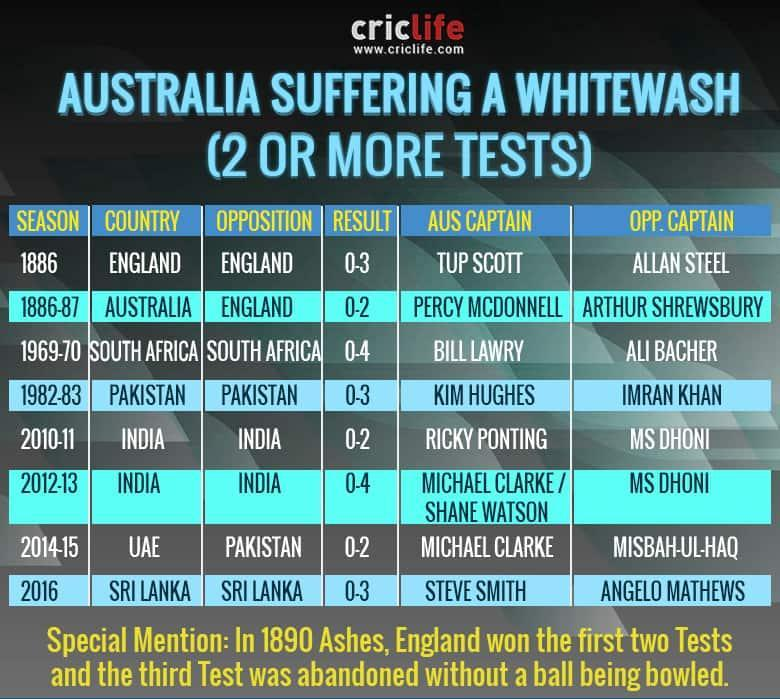Where was the England-Australia test series played during 1886-87?
Answer the question with a short phrase. AUSTRALIA Who was the captain of Pakistan in the test series against Australia in 1982-83? IMRAN KHAN What is the match result of England-Australia test series in 1886? 0-3 Who was the captain of Australia during the India-Australia test series in 2010-11? RICKY PONTING Where was the Pakistan-Australia test series played during 2014-15? UAE Who won the test series between South Africa-Australia in 1969-70? SOUTH AFRICA Who won the test series between India-Australia in 2012-13? INDIA Who was the captain of India during the India-Australia test series in 2010-11? MS DHONI 